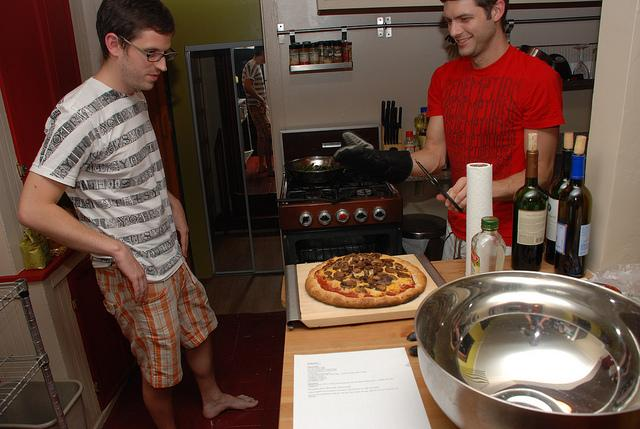How many bottles of wine are to the right in front to the man who is cutting the pizza?

Choices:
A) one
B) three
C) two
D) four three 